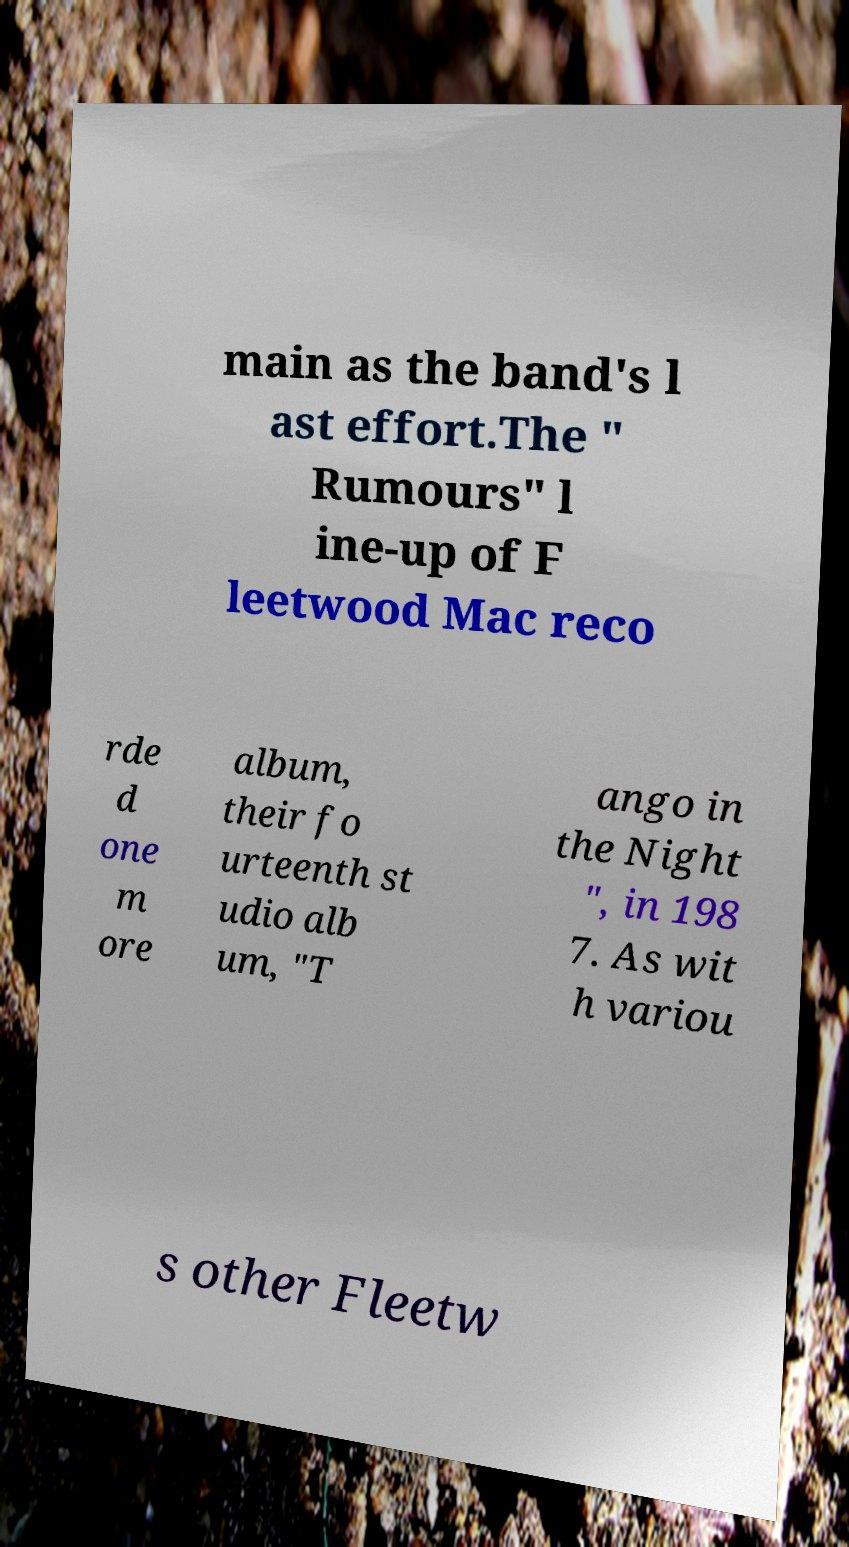Can you accurately transcribe the text from the provided image for me? main as the band's l ast effort.The " Rumours" l ine-up of F leetwood Mac reco rde d one m ore album, their fo urteenth st udio alb um, "T ango in the Night ", in 198 7. As wit h variou s other Fleetw 